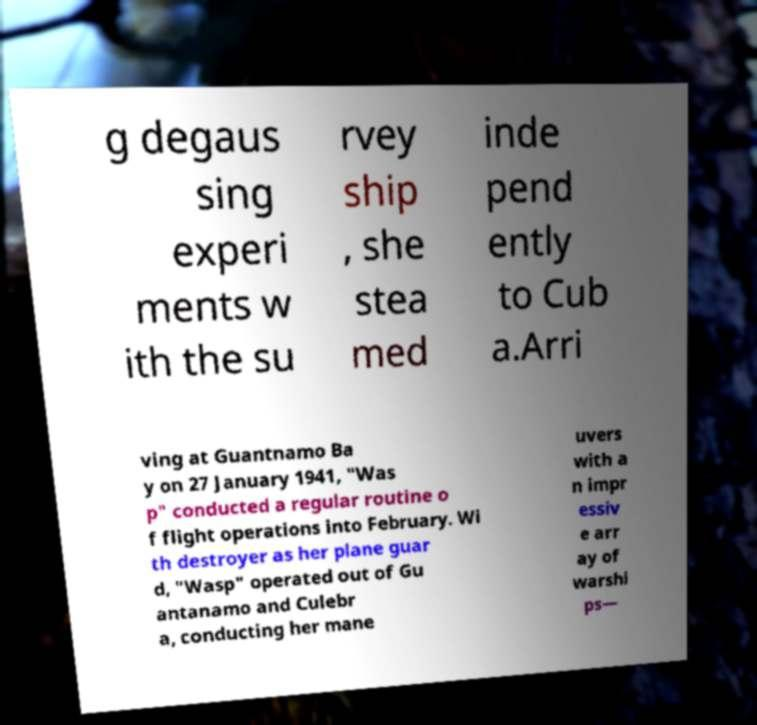For documentation purposes, I need the text within this image transcribed. Could you provide that? g degaus sing experi ments w ith the su rvey ship , she stea med inde pend ently to Cub a.Arri ving at Guantnamo Ba y on 27 January 1941, "Was p" conducted a regular routine o f flight operations into February. Wi th destroyer as her plane guar d, "Wasp" operated out of Gu antanamo and Culebr a, conducting her mane uvers with a n impr essiv e arr ay of warshi ps— 